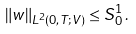Convert formula to latex. <formula><loc_0><loc_0><loc_500><loc_500>\| w \| _ { L ^ { 2 } ( 0 , T ; V ) } \leq S ^ { 1 } _ { 0 } \, .</formula> 